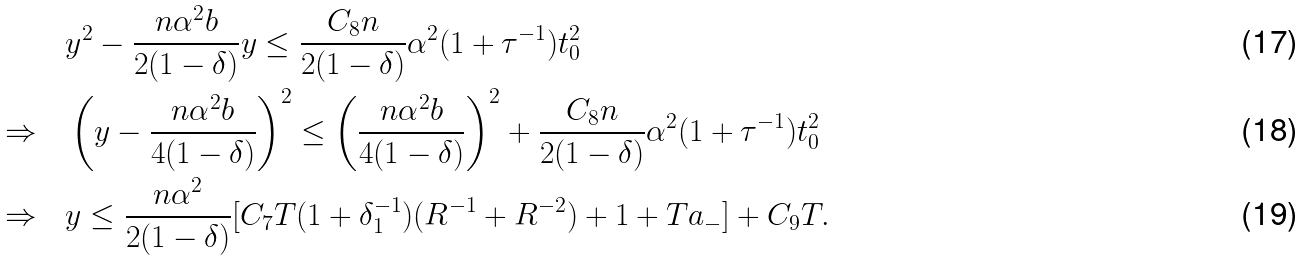<formula> <loc_0><loc_0><loc_500><loc_500>& y ^ { 2 } - \frac { n \alpha ^ { 2 } b } { 2 ( 1 - \delta ) } y \leq \frac { C _ { 8 } n } { 2 ( 1 - \delta ) } \alpha ^ { 2 } ( 1 + \tau ^ { - 1 } ) t _ { 0 } ^ { 2 } \\ \Rightarrow \quad & \left ( y - \frac { n \alpha ^ { 2 } b } { 4 ( 1 - \delta ) } \right ) ^ { 2 } \leq \left ( \frac { n \alpha ^ { 2 } b } { 4 ( 1 - \delta ) } \right ) ^ { 2 } + \frac { C _ { 8 } n } { 2 ( 1 - \delta ) } \alpha ^ { 2 } ( 1 + \tau ^ { - 1 } ) t _ { 0 } ^ { 2 } \\ \Rightarrow \quad & y \leq \frac { n \alpha ^ { 2 } } { 2 ( 1 - \delta ) } [ C _ { 7 } T ( 1 + \delta _ { 1 } ^ { - 1 } ) ( R ^ { - 1 } + R ^ { - 2 } ) + 1 + T a _ { - } ] + C _ { 9 } T .</formula> 